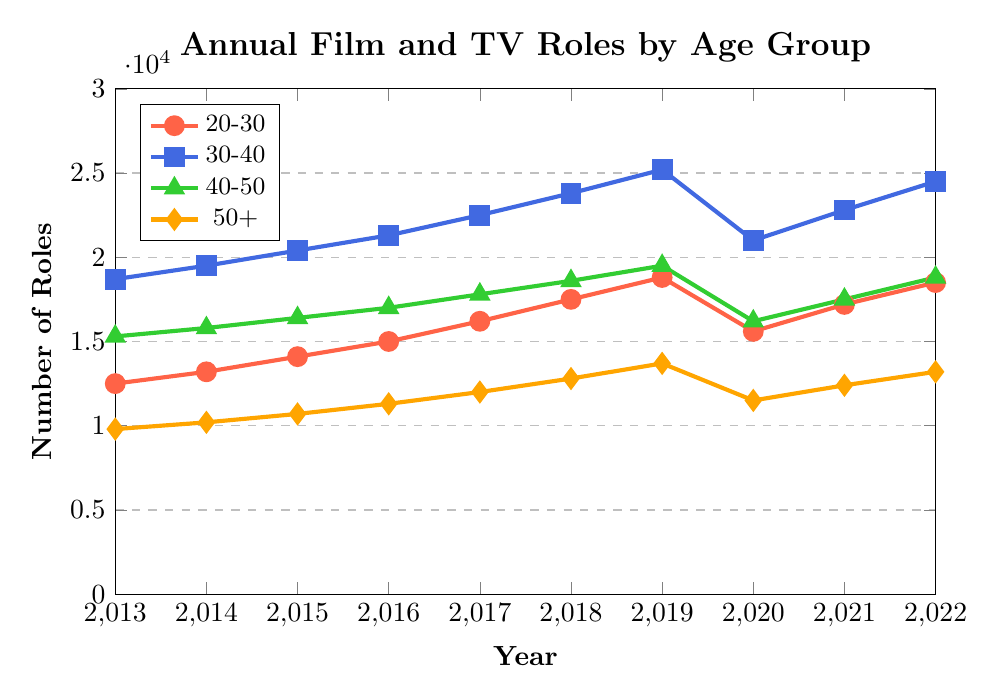Which age group saw the most significant increase in roles from 2013 to 2022? To find the age group with the most significant increase, we need to calculate the difference in the number of roles in 2022 and 2013 for each age group: 20-30 (18500-12500), 30-40 (24500-18700), 40-50 (18800-15300), and 50+ (13200-9800). The difference for each is 6000, 5800, 3500, and 3400, respectively. Thus, the 20-30 age group saw the most significant increase.
Answer: 20-30 Which year saw the highest number of roles for actors aged 30-40? To determine the year with the highest number of roles for the 30-40 age group, we examine the data for each year: 2013 (18700), 2014 (19500), 2015 (20400), 2016 (21300), 2017 (22500), 2018 (23800), 2019 (25200), 2020 (21000), 2021 (22800), and 2022 (24500). The highest value is 25200 in 2019.
Answer: 2019 How did the number of roles for actors aged 50+ change between 2019 and 2020? We need to compare the number of roles in 2019 and 2020 for the 50+ age group: 2019 (13700) and 2020 (11500). The difference is 13700 - 11500 = 2200, so the number decreased by 2200 roles.
Answer: Decreased by 2200 What is the overall trend for actors aged 20-30 over the decade? Observing the data for the 20-30 age group from 2013 (12500) to 2022 (18500), we notice a general upward trend. The only significant drop is in 2020 (15600), likely due to external factors such as the pandemic. Apart from this dip, the trend consistently increases.
Answer: Upward trend Which age group had the least number of roles in 2022? To find the age group with the least number of roles in 2022, compare the values for each age group: 20-30 (18500), 30-40 (24500), 40-50 (18800), and 50+ (13200). The 50+ age group had the least number of roles.
Answer: 50+ What was the average number of roles for actors aged 40-50 across the decade? To calculate the average, we sum the values for each year for the 40-50 age group: 2013 (15300), 2014 (15800), 2015 (16400), 2016 (17000), 2017 (17800), 2018 (18600), 2019 (19500), 2020 (16200), 2021 (17500), and 2022 (18800). The sum is 162600. Dividing by 10 (number of years), we get an average of 16260.
Answer: 16260 Did any age group experience a decrease in the number of roles from 2018 to 2019? Comparing the number of roles from 2018 to 2019 for each age group: 20-30 (17500 to 18800), 30-40 (23800 to 25200), 40-50 (18600 to 19500), 50+ (12800 to 13700). None of the age groups experienced a decrease during this period.
Answer: No What was the percentage increase in roles for the 20-30 age group from 2013 to 2022? Calculate the percentage increase by using the formula: [(Final Value - Initial Value) / Initial Value] * 100. For the 20-30 age group from 2013 (12500) to 2022 (18500): [(18500 - 12500) / 12500] * 100 = 48%.
Answer: 48% Which age group saw the most noticeable drop in roles during 2020? To find the most noticeable drop, calculate the difference in roles from 2019 to 2020 for each age group: 20-30 (18800-15600=3200), 30-40 (25200-21000=4200), 40-50 (19500-16200=3300), 50+ (13700-11500=2200). The age group 30-40 experienced the most significant drop of 4200 roles.
Answer: 30-40 